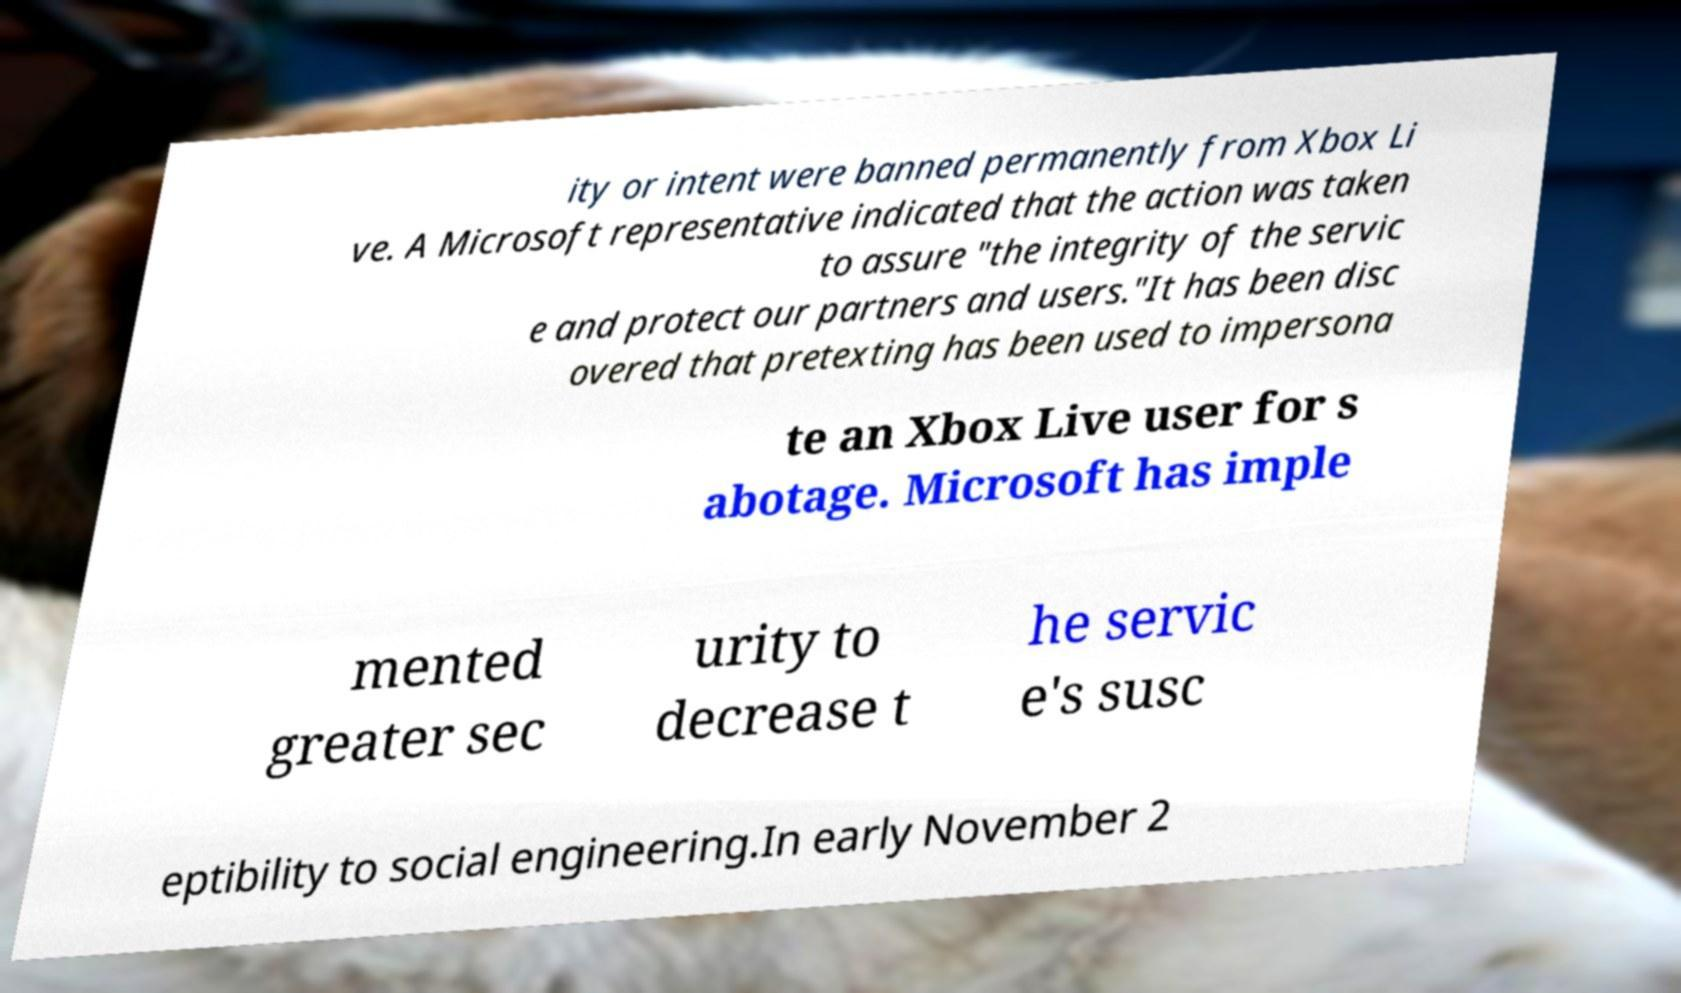For documentation purposes, I need the text within this image transcribed. Could you provide that? ity or intent were banned permanently from Xbox Li ve. A Microsoft representative indicated that the action was taken to assure "the integrity of the servic e and protect our partners and users."It has been disc overed that pretexting has been used to impersona te an Xbox Live user for s abotage. Microsoft has imple mented greater sec urity to decrease t he servic e's susc eptibility to social engineering.In early November 2 